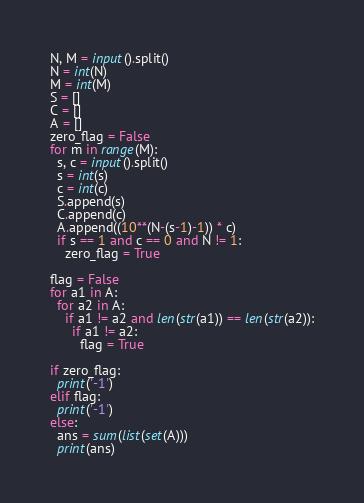<code> <loc_0><loc_0><loc_500><loc_500><_Python_>N, M = input().split()
N = int(N)
M = int(M)
S = []
C = []
A = []
zero_flag = False
for m in range(M):
  s, c = input().split()
  s = int(s)
  c = int(c)
  S.append(s)
  C.append(c)
  A.append((10**(N-(s-1)-1)) * c)
  if s == 1 and c == 0 and N != 1:
    zero_flag = True

flag = False
for a1 in A:
  for a2 in A:
    if a1 != a2 and len(str(a1)) == len(str(a2)):
      if a1 != a2:
        flag = True
  
if zero_flag:
  print('-1')
elif flag:
  print('-1')
else:
  ans = sum(list(set(A)))
  print(ans)
</code> 